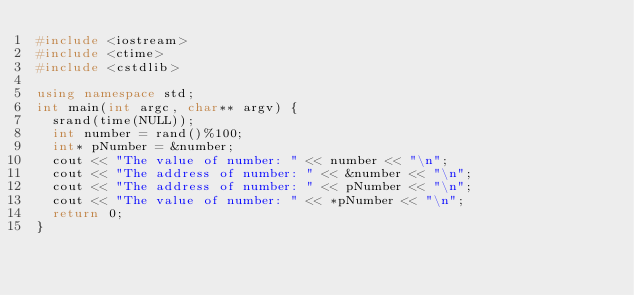Convert code to text. <code><loc_0><loc_0><loc_500><loc_500><_C++_>#include <iostream>
#include <ctime>
#include <cstdlib>

using namespace std;
int main(int argc, char** argv) {
	srand(time(NULL));
	int number = rand()%100;
	int* pNumber = &number;
	cout << "The value of number: " << number << "\n";
	cout << "The address of number: " << &number << "\n";
	cout << "The address of number: " << pNumber << "\n";
	cout << "The value of number: " << *pNumber << "\n";
	return 0;
}
</code> 